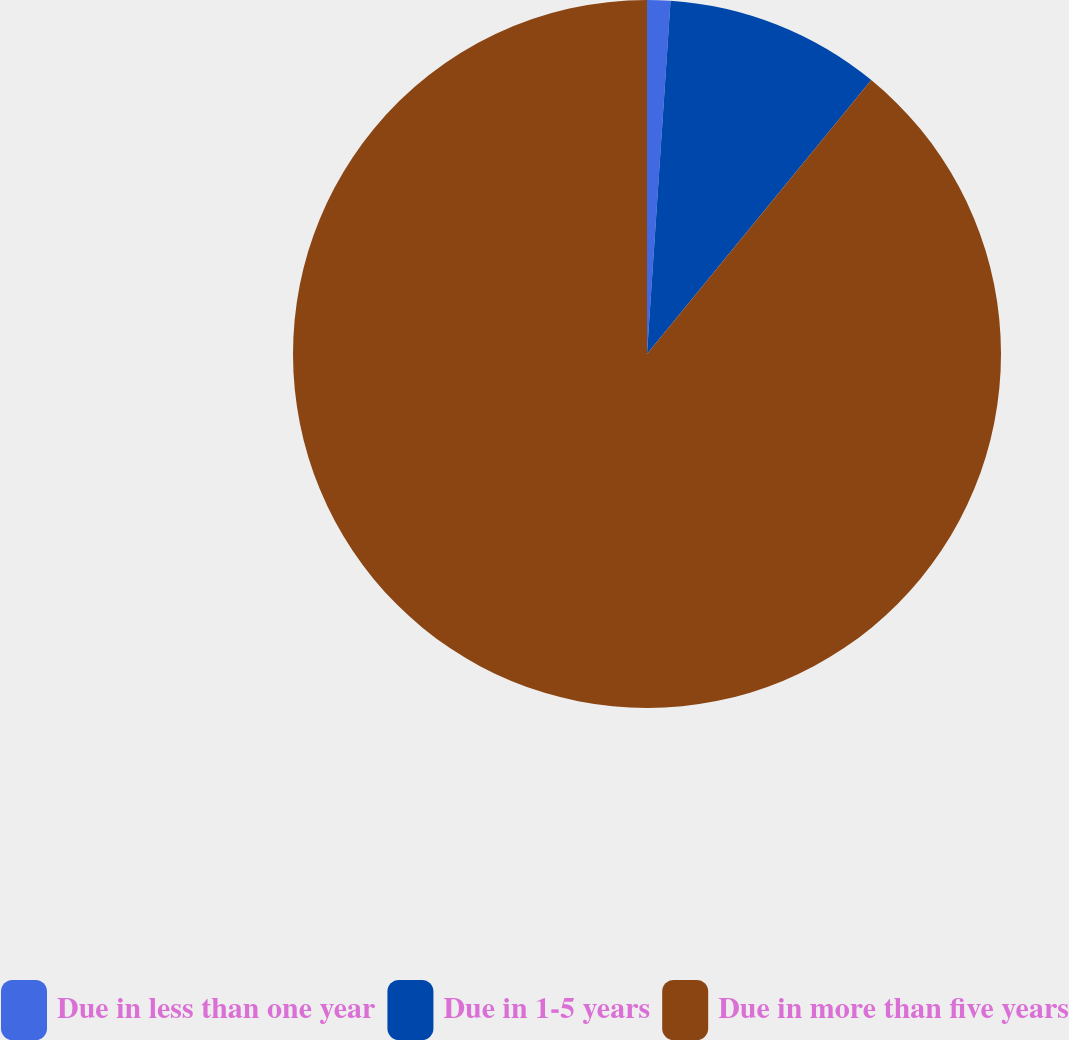Convert chart to OTSL. <chart><loc_0><loc_0><loc_500><loc_500><pie_chart><fcel>Due in less than one year<fcel>Due in 1-5 years<fcel>Due in more than five years<nl><fcel>1.06%<fcel>9.86%<fcel>89.08%<nl></chart> 